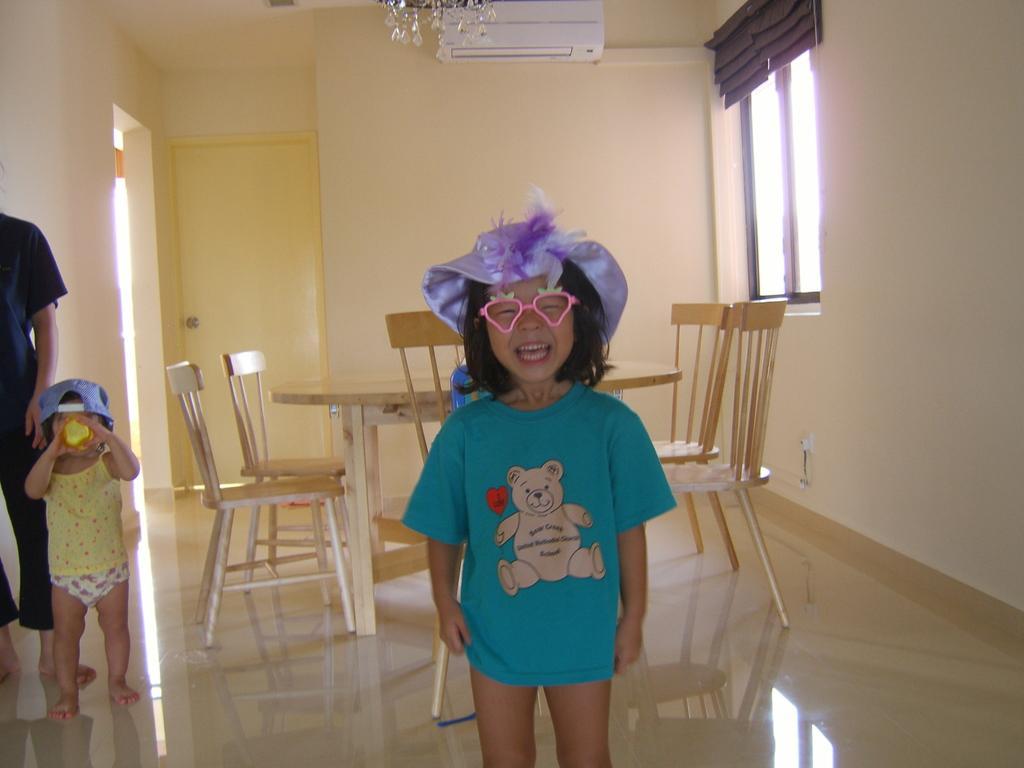Could you give a brief overview of what you see in this image? This picture is clicked inside the room. Girl in blue t-shirt wearing violet cap is smiling and on left corner of picture, we see person in black shirt and baby in yellow t-shirt is wearing blue cap, is drinking some liquid from the bottle. Behind them, we see dining table around which chairs are placed and behind that, we see white wall and yellow door and on right of the picture, we see windows. 